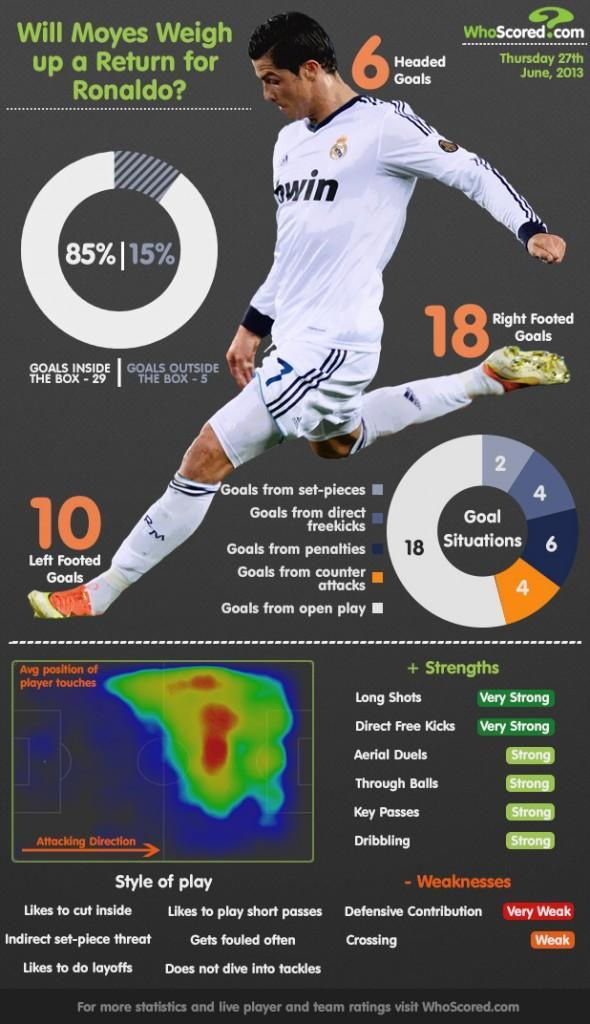How many goals were played inside the box by Ronaldo as of June, 2013?
Answer the question with a short phrase. 29 In which type of kicks, Ronaldo is very strong? Direct Free Kicks How many goals were made from open play by Ronaldo as of June, 2013? 18 How many goals were taken from counter attacks by Ronaldo as of June, 2013? 4 In which type of shots, Ronaldo is very strong? Long shots What percentage of goals taken by Ronaldo were inside the box as of June, 2013? 85% How many penalty goals were taken by Ronaldo as of June, 2013? 6 What percentage of goals taken by Ronaldo were outside the box as of June, 2013? 15% How many goals were taken from direct free kicks by Ronaldo as of June, 2013? 4 How many goals were played outside the box by Ronaldo as of June, 2013? 5 